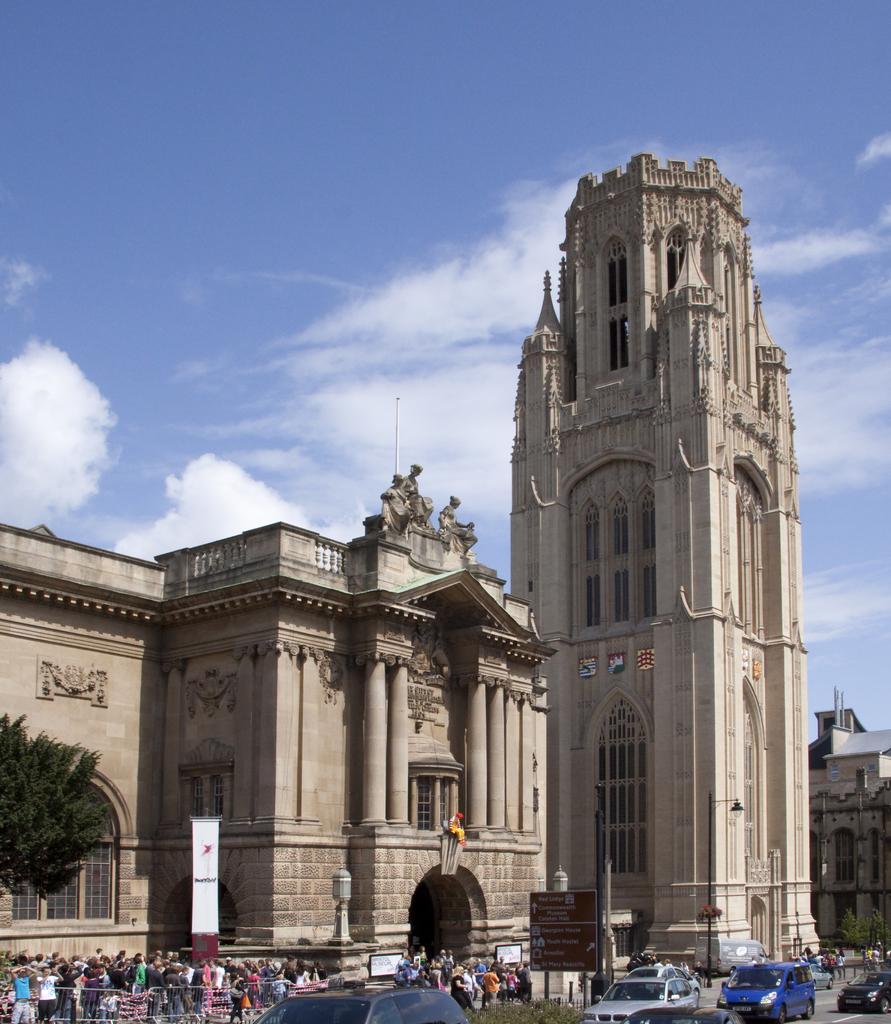Please provide a concise description of this image. In this image we can see buildings, statues, persons walking on the road, motor vehicles on the road, street poles, street lights, trees and sky with clouds in the background. 